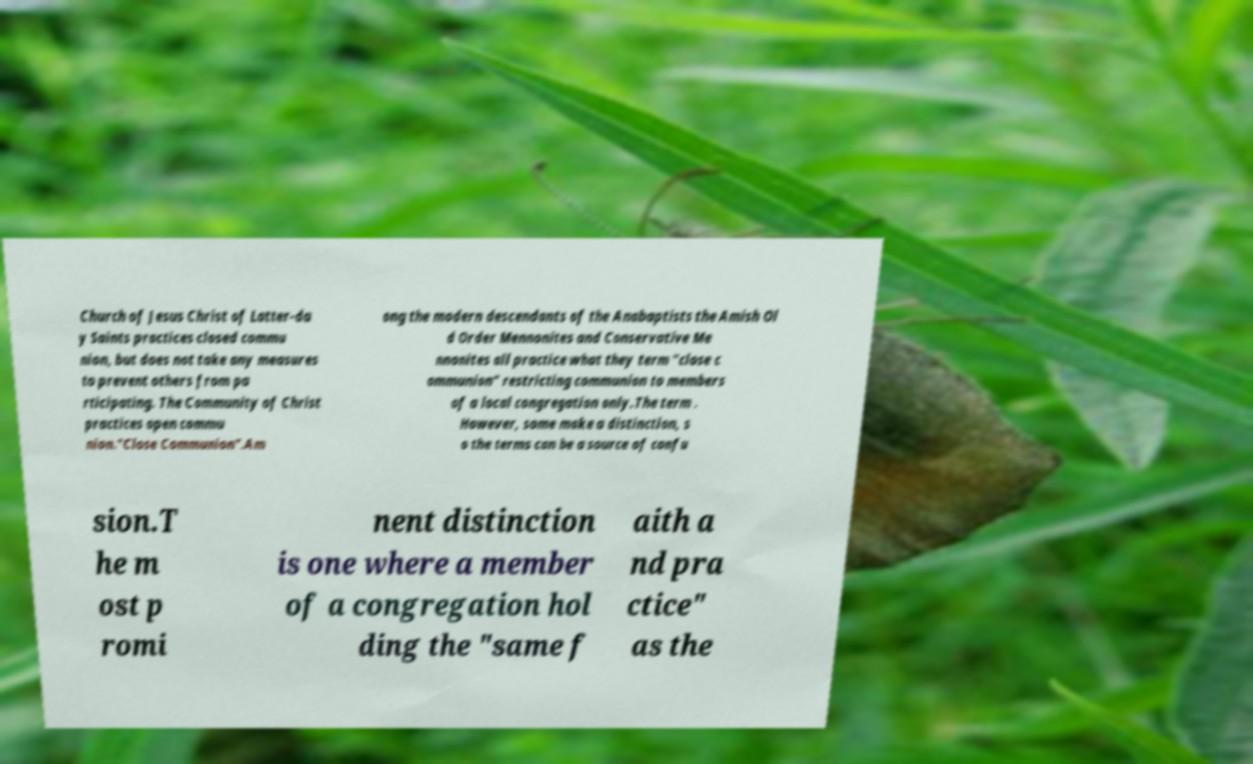There's text embedded in this image that I need extracted. Can you transcribe it verbatim? Church of Jesus Christ of Latter-da y Saints practices closed commu nion, but does not take any measures to prevent others from pa rticipating. The Community of Christ practices open commu nion."Close Communion".Am ong the modern descendants of the Anabaptists the Amish Ol d Order Mennonites and Conservative Me nnonites all practice what they term "close c ommunion" restricting communion to members of a local congregation only.The term . However, some make a distinction, s o the terms can be a source of confu sion.T he m ost p romi nent distinction is one where a member of a congregation hol ding the "same f aith a nd pra ctice" as the 